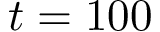<formula> <loc_0><loc_0><loc_500><loc_500>t = 1 0 0</formula> 